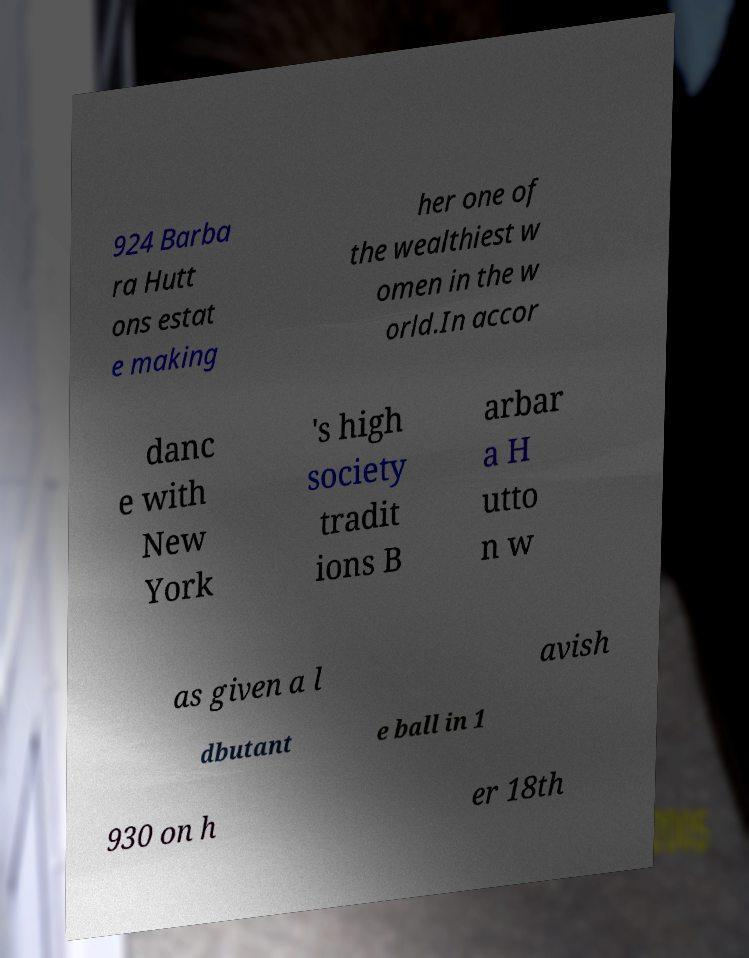For documentation purposes, I need the text within this image transcribed. Could you provide that? 924 Barba ra Hutt ons estat e making her one of the wealthiest w omen in the w orld.In accor danc e with New York 's high society tradit ions B arbar a H utto n w as given a l avish dbutant e ball in 1 930 on h er 18th 